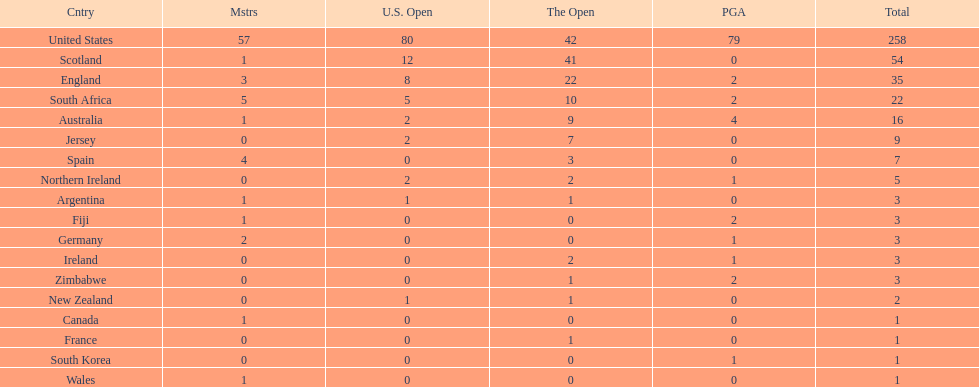Would you mind parsing the complete table? {'header': ['Cntry', 'Mstrs', 'U.S. Open', 'The Open', 'PGA', 'Total'], 'rows': [['United States', '57', '80', '42', '79', '258'], ['Scotland', '1', '12', '41', '0', '54'], ['England', '3', '8', '22', '2', '35'], ['South Africa', '5', '5', '10', '2', '22'], ['Australia', '1', '2', '9', '4', '16'], ['Jersey', '0', '2', '7', '0', '9'], ['Spain', '4', '0', '3', '0', '7'], ['Northern Ireland', '0', '2', '2', '1', '5'], ['Argentina', '1', '1', '1', '0', '3'], ['Fiji', '1', '0', '0', '2', '3'], ['Germany', '2', '0', '0', '1', '3'], ['Ireland', '0', '0', '2', '1', '3'], ['Zimbabwe', '0', '0', '1', '2', '3'], ['New Zealand', '0', '1', '1', '0', '2'], ['Canada', '1', '0', '0', '0', '1'], ['France', '0', '0', '1', '0', '1'], ['South Korea', '0', '0', '0', '1', '1'], ['Wales', '1', '0', '0', '0', '1']]} Combined, how many winning golfers does england and wales have in the masters? 4. 